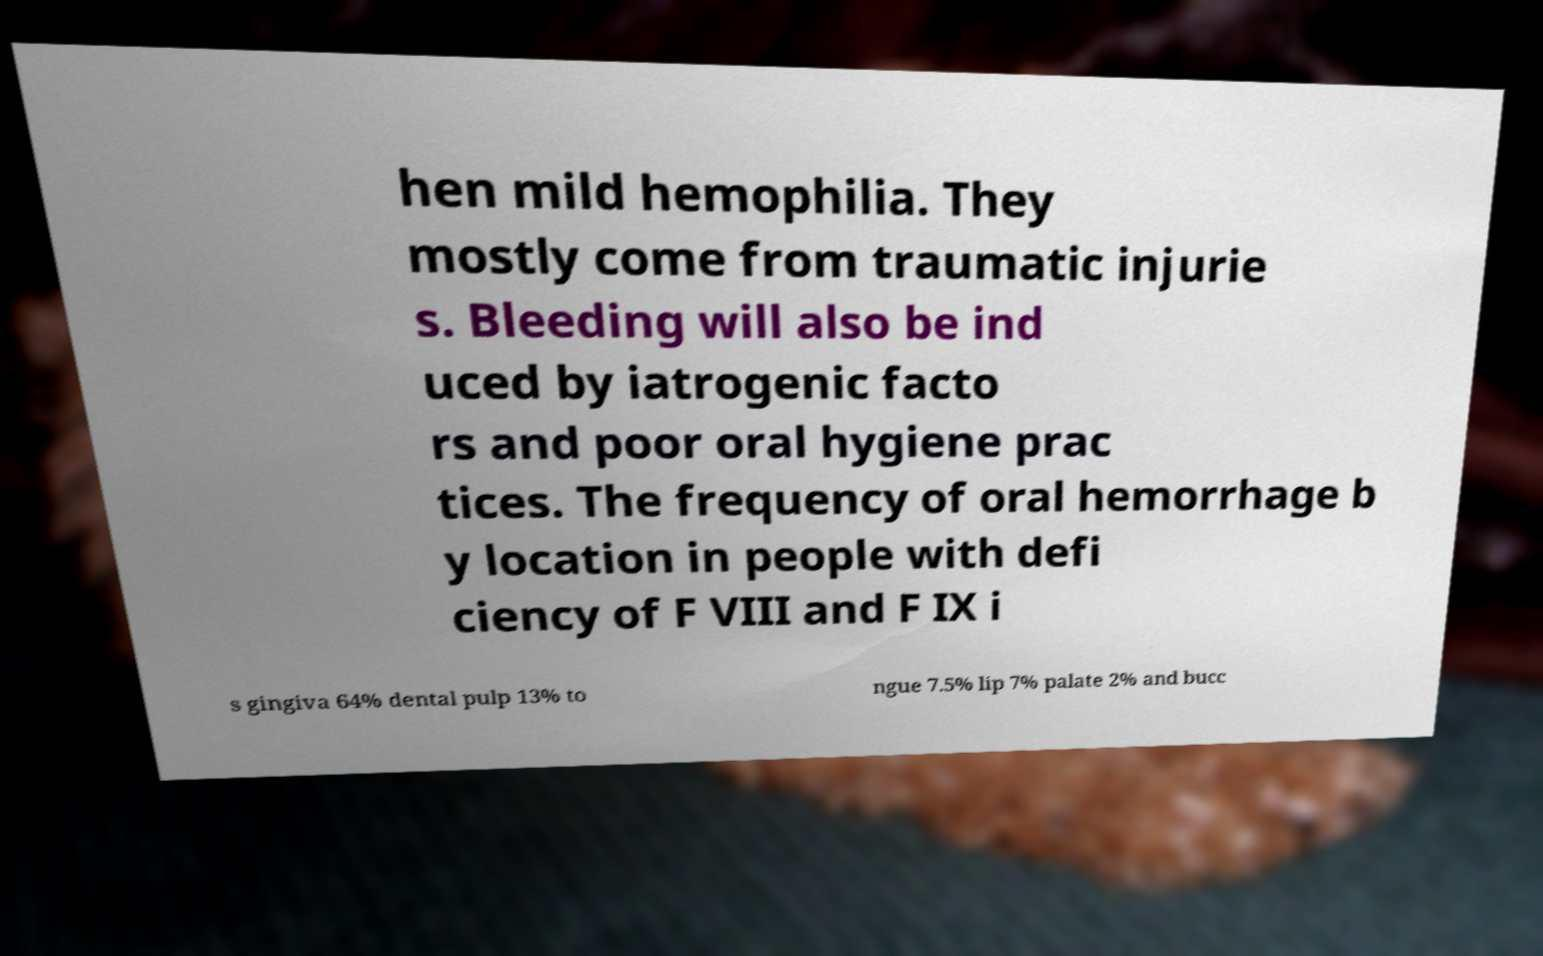I need the written content from this picture converted into text. Can you do that? hen mild hemophilia. They mostly come from traumatic injurie s. Bleeding will also be ind uced by iatrogenic facto rs and poor oral hygiene prac tices. The frequency of oral hemorrhage b y location in people with defi ciency of F VIII and F IX i s gingiva 64% dental pulp 13% to ngue 7.5% lip 7% palate 2% and bucc 